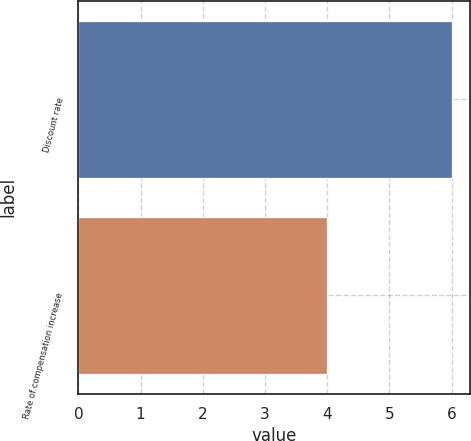Convert chart to OTSL. <chart><loc_0><loc_0><loc_500><loc_500><bar_chart><fcel>Discount rate<fcel>Rate of compensation increase<nl><fcel>6<fcel>4<nl></chart> 